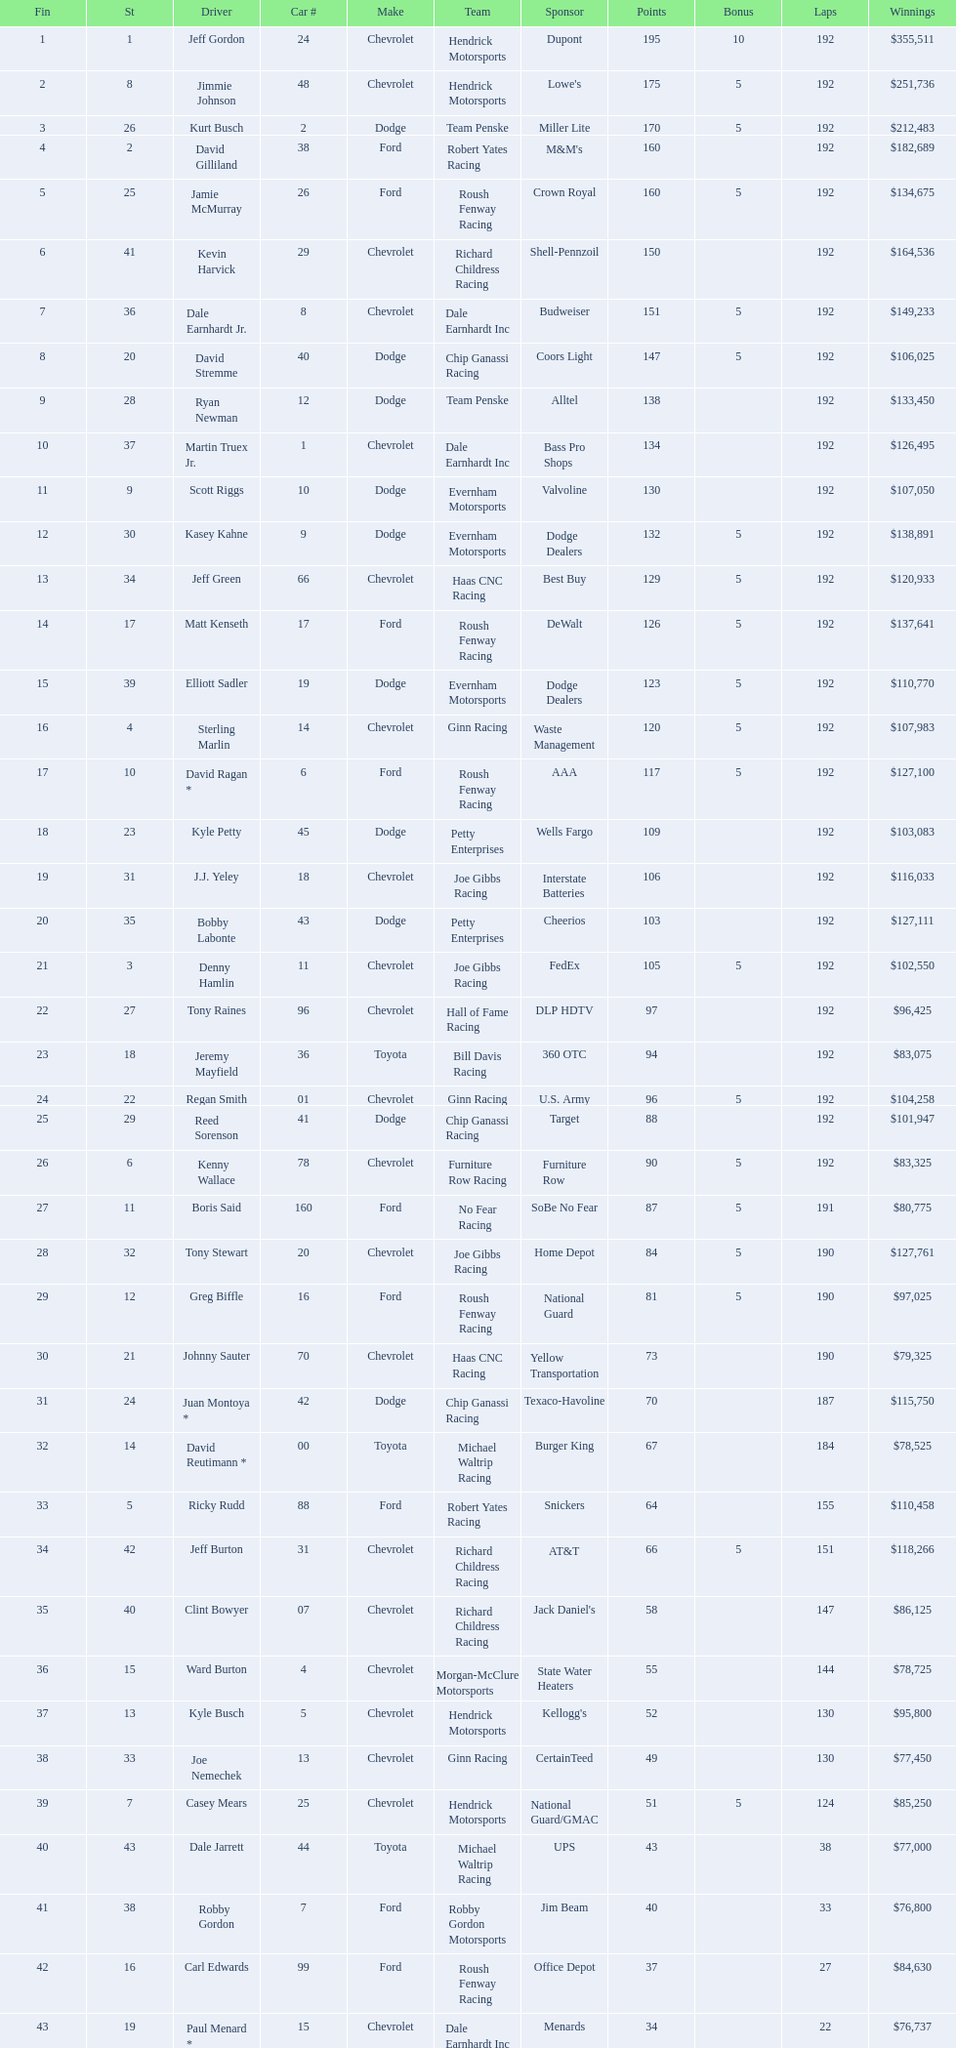How many racers were awarded a 5-point bonus in the competition? 19. 